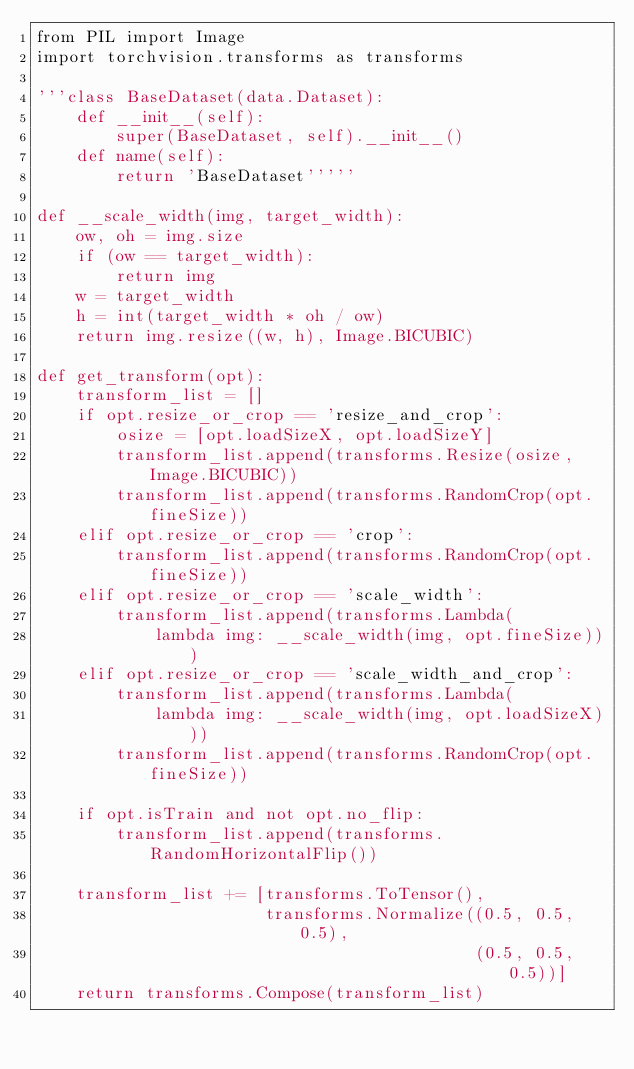Convert code to text. <code><loc_0><loc_0><loc_500><loc_500><_Python_>from PIL import Image
import torchvision.transforms as transforms

'''class BaseDataset(data.Dataset):
    def __init__(self):
        super(BaseDataset, self).__init__()
    def name(self):
        return 'BaseDataset'''''

def __scale_width(img, target_width):
    ow, oh = img.size
    if (ow == target_width):
        return img
    w = target_width
    h = int(target_width * oh / ow)
    return img.resize((w, h), Image.BICUBIC)

def get_transform(opt):
    transform_list = []
    if opt.resize_or_crop == 'resize_and_crop':
        osize = [opt.loadSizeX, opt.loadSizeY]
        transform_list.append(transforms.Resize(osize, Image.BICUBIC))
        transform_list.append(transforms.RandomCrop(opt.fineSize))
    elif opt.resize_or_crop == 'crop':
        transform_list.append(transforms.RandomCrop(opt.fineSize))
    elif opt.resize_or_crop == 'scale_width':
        transform_list.append(transforms.Lambda(
            lambda img: __scale_width(img, opt.fineSize)))
    elif opt.resize_or_crop == 'scale_width_and_crop':
        transform_list.append(transforms.Lambda(
            lambda img: __scale_width(img, opt.loadSizeX)))
        transform_list.append(transforms.RandomCrop(opt.fineSize))

    if opt.isTrain and not opt.no_flip:
        transform_list.append(transforms.RandomHorizontalFlip())

    transform_list += [transforms.ToTensor(),
                       transforms.Normalize((0.5, 0.5, 0.5),
                                            (0.5, 0.5, 0.5))]
    return transforms.Compose(transform_list)


</code> 